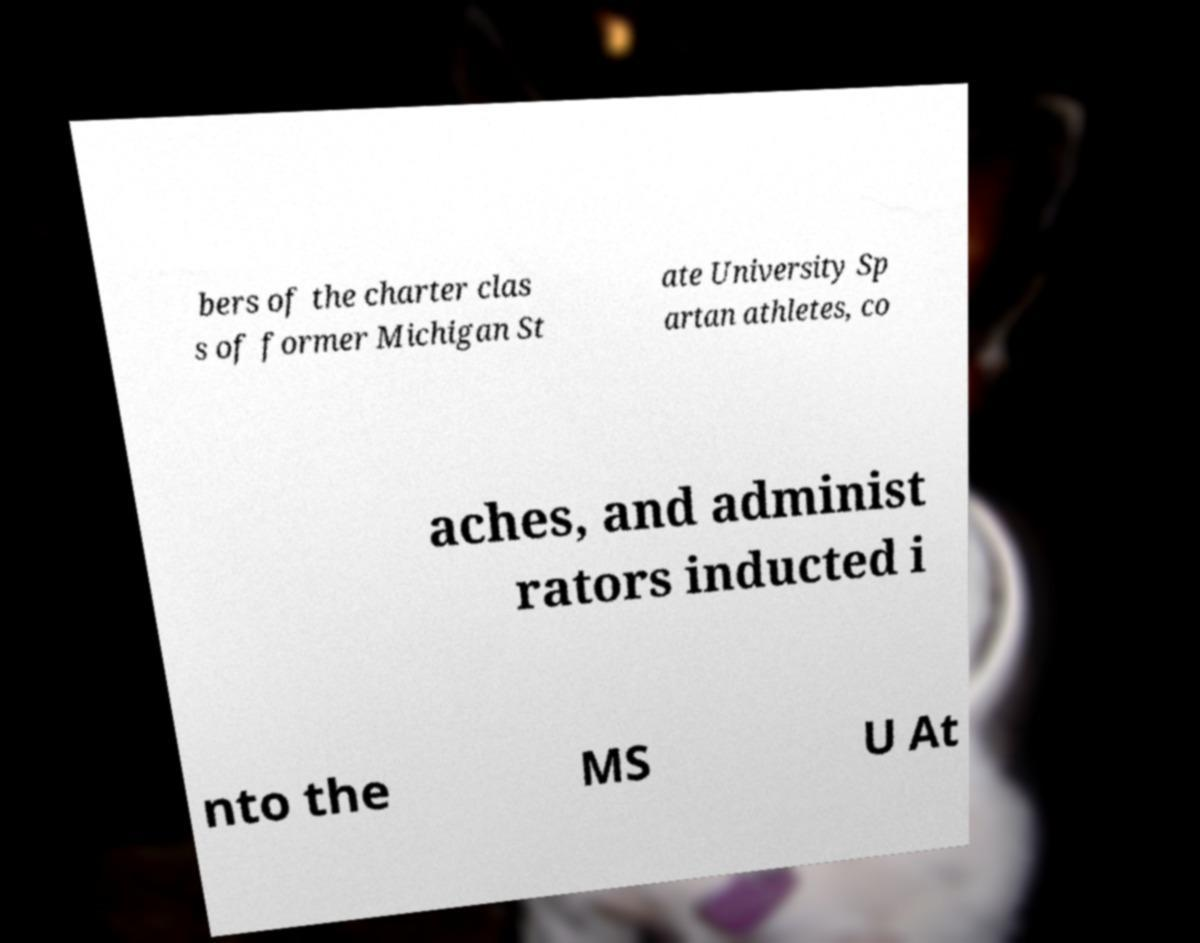Please identify and transcribe the text found in this image. bers of the charter clas s of former Michigan St ate University Sp artan athletes, co aches, and administ rators inducted i nto the MS U At 